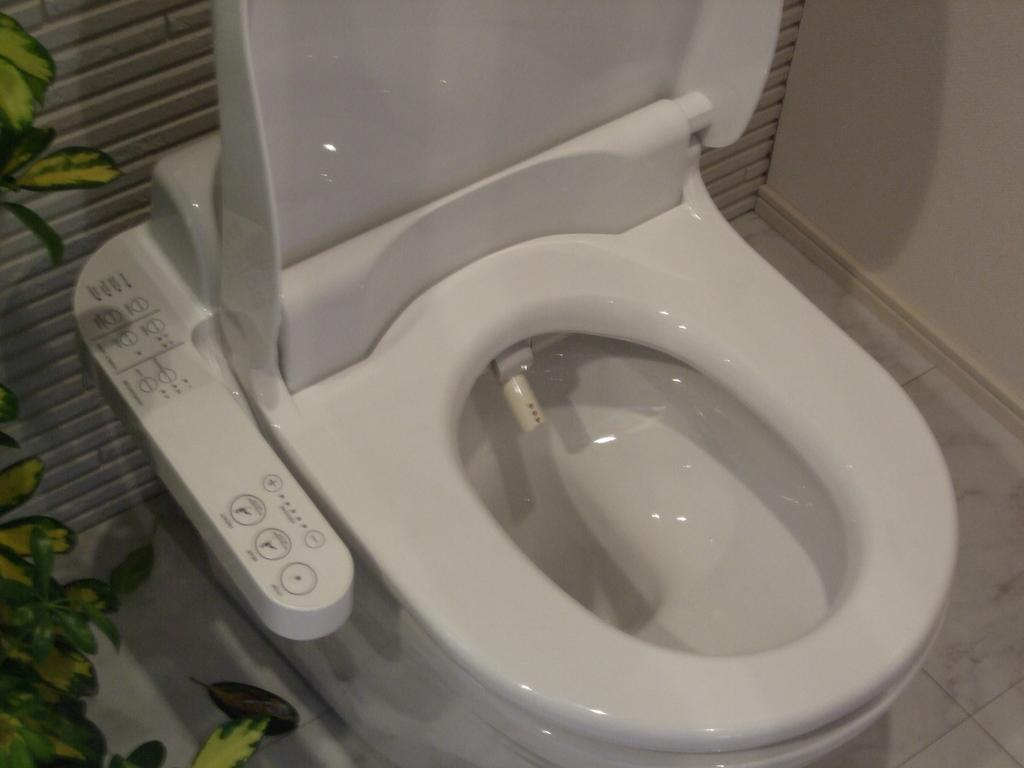What is the main object in the image? There is a toilet seat in the image. What can be seen in the background of the image? There is a plant and a wall in the background of the image. What type of alarm can be heard going off in the image? There is no alarm present in the image, so it cannot be heard. 